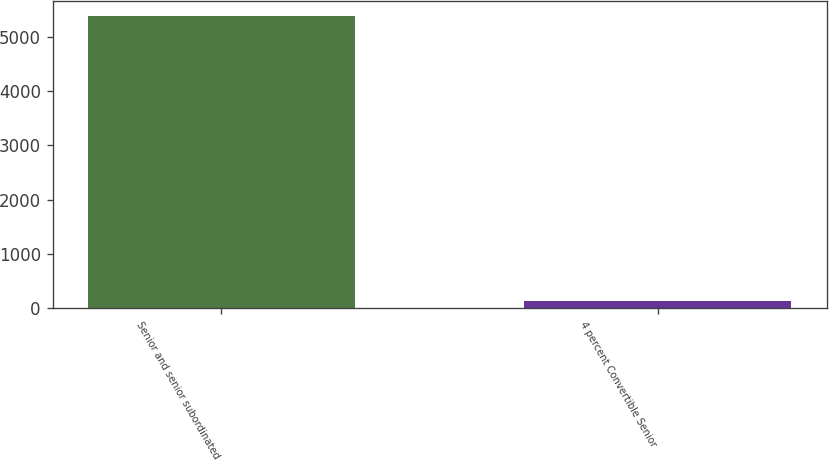Convert chart to OTSL. <chart><loc_0><loc_0><loc_500><loc_500><bar_chart><fcel>Senior and senior subordinated<fcel>4 percent Convertible Senior<nl><fcel>5381<fcel>136<nl></chart> 